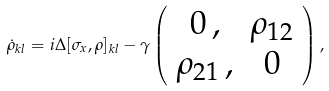<formula> <loc_0><loc_0><loc_500><loc_500>\dot { \rho } _ { k l } = i \Delta [ \sigma _ { x } , \rho ] _ { k l } - \gamma \left ( \begin{array} { c c } 0 \, , & \rho _ { 1 2 } \\ \rho _ { 2 1 } \, , & 0 \end{array} \right ) ,</formula> 